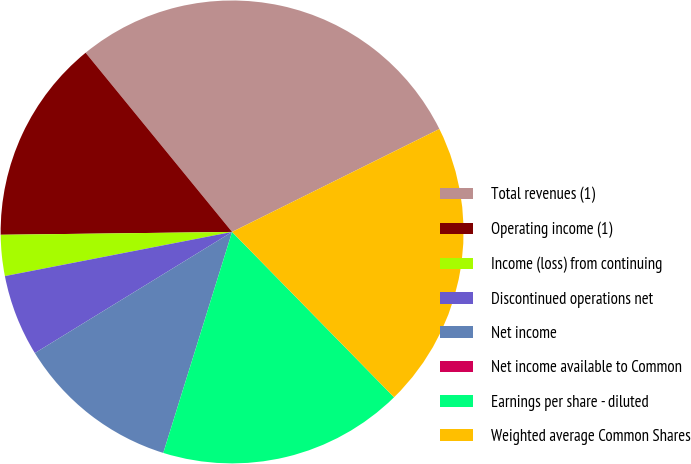Convert chart to OTSL. <chart><loc_0><loc_0><loc_500><loc_500><pie_chart><fcel>Total revenues (1)<fcel>Operating income (1)<fcel>Income (loss) from continuing<fcel>Discontinued operations net<fcel>Net income<fcel>Net income available to Common<fcel>Earnings per share - diluted<fcel>Weighted average Common Shares<nl><fcel>28.57%<fcel>14.29%<fcel>2.86%<fcel>5.71%<fcel>11.43%<fcel>0.0%<fcel>17.14%<fcel>20.0%<nl></chart> 